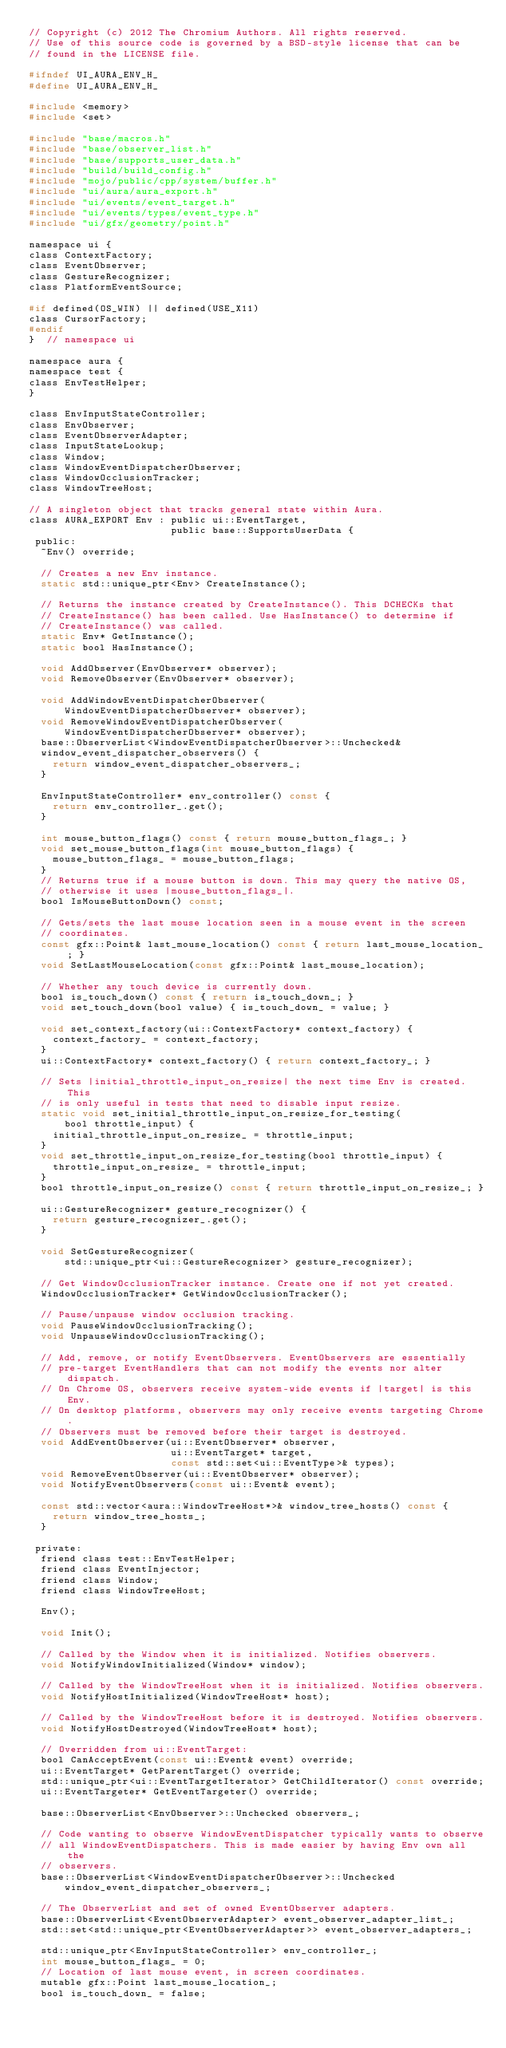Convert code to text. <code><loc_0><loc_0><loc_500><loc_500><_C_>// Copyright (c) 2012 The Chromium Authors. All rights reserved.
// Use of this source code is governed by a BSD-style license that can be
// found in the LICENSE file.

#ifndef UI_AURA_ENV_H_
#define UI_AURA_ENV_H_

#include <memory>
#include <set>

#include "base/macros.h"
#include "base/observer_list.h"
#include "base/supports_user_data.h"
#include "build/build_config.h"
#include "mojo/public/cpp/system/buffer.h"
#include "ui/aura/aura_export.h"
#include "ui/events/event_target.h"
#include "ui/events/types/event_type.h"
#include "ui/gfx/geometry/point.h"

namespace ui {
class ContextFactory;
class EventObserver;
class GestureRecognizer;
class PlatformEventSource;

#if defined(OS_WIN) || defined(USE_X11)
class CursorFactory;
#endif
}  // namespace ui

namespace aura {
namespace test {
class EnvTestHelper;
}

class EnvInputStateController;
class EnvObserver;
class EventObserverAdapter;
class InputStateLookup;
class Window;
class WindowEventDispatcherObserver;
class WindowOcclusionTracker;
class WindowTreeHost;

// A singleton object that tracks general state within Aura.
class AURA_EXPORT Env : public ui::EventTarget,
                        public base::SupportsUserData {
 public:
  ~Env() override;

  // Creates a new Env instance.
  static std::unique_ptr<Env> CreateInstance();

  // Returns the instance created by CreateInstance(). This DCHECKs that
  // CreateInstance() has been called. Use HasInstance() to determine if
  // CreateInstance() was called.
  static Env* GetInstance();
  static bool HasInstance();

  void AddObserver(EnvObserver* observer);
  void RemoveObserver(EnvObserver* observer);

  void AddWindowEventDispatcherObserver(
      WindowEventDispatcherObserver* observer);
  void RemoveWindowEventDispatcherObserver(
      WindowEventDispatcherObserver* observer);
  base::ObserverList<WindowEventDispatcherObserver>::Unchecked&
  window_event_dispatcher_observers() {
    return window_event_dispatcher_observers_;
  }

  EnvInputStateController* env_controller() const {
    return env_controller_.get();
  }

  int mouse_button_flags() const { return mouse_button_flags_; }
  void set_mouse_button_flags(int mouse_button_flags) {
    mouse_button_flags_ = mouse_button_flags;
  }
  // Returns true if a mouse button is down. This may query the native OS,
  // otherwise it uses |mouse_button_flags_|.
  bool IsMouseButtonDown() const;

  // Gets/sets the last mouse location seen in a mouse event in the screen
  // coordinates.
  const gfx::Point& last_mouse_location() const { return last_mouse_location_; }
  void SetLastMouseLocation(const gfx::Point& last_mouse_location);

  // Whether any touch device is currently down.
  bool is_touch_down() const { return is_touch_down_; }
  void set_touch_down(bool value) { is_touch_down_ = value; }

  void set_context_factory(ui::ContextFactory* context_factory) {
    context_factory_ = context_factory;
  }
  ui::ContextFactory* context_factory() { return context_factory_; }

  // Sets |initial_throttle_input_on_resize| the next time Env is created. This
  // is only useful in tests that need to disable input resize.
  static void set_initial_throttle_input_on_resize_for_testing(
      bool throttle_input) {
    initial_throttle_input_on_resize_ = throttle_input;
  }
  void set_throttle_input_on_resize_for_testing(bool throttle_input) {
    throttle_input_on_resize_ = throttle_input;
  }
  bool throttle_input_on_resize() const { return throttle_input_on_resize_; }

  ui::GestureRecognizer* gesture_recognizer() {
    return gesture_recognizer_.get();
  }

  void SetGestureRecognizer(
      std::unique_ptr<ui::GestureRecognizer> gesture_recognizer);

  // Get WindowOcclusionTracker instance. Create one if not yet created.
  WindowOcclusionTracker* GetWindowOcclusionTracker();

  // Pause/unpause window occlusion tracking.
  void PauseWindowOcclusionTracking();
  void UnpauseWindowOcclusionTracking();

  // Add, remove, or notify EventObservers. EventObservers are essentially
  // pre-target EventHandlers that can not modify the events nor alter dispatch.
  // On Chrome OS, observers receive system-wide events if |target| is this Env.
  // On desktop platforms, observers may only receive events targeting Chrome.
  // Observers must be removed before their target is destroyed.
  void AddEventObserver(ui::EventObserver* observer,
                        ui::EventTarget* target,
                        const std::set<ui::EventType>& types);
  void RemoveEventObserver(ui::EventObserver* observer);
  void NotifyEventObservers(const ui::Event& event);

  const std::vector<aura::WindowTreeHost*>& window_tree_hosts() const {
    return window_tree_hosts_;
  }

 private:
  friend class test::EnvTestHelper;
  friend class EventInjector;
  friend class Window;
  friend class WindowTreeHost;

  Env();

  void Init();

  // Called by the Window when it is initialized. Notifies observers.
  void NotifyWindowInitialized(Window* window);

  // Called by the WindowTreeHost when it is initialized. Notifies observers.
  void NotifyHostInitialized(WindowTreeHost* host);

  // Called by the WindowTreeHost before it is destroyed. Notifies observers.
  void NotifyHostDestroyed(WindowTreeHost* host);

  // Overridden from ui::EventTarget:
  bool CanAcceptEvent(const ui::Event& event) override;
  ui::EventTarget* GetParentTarget() override;
  std::unique_ptr<ui::EventTargetIterator> GetChildIterator() const override;
  ui::EventTargeter* GetEventTargeter() override;

  base::ObserverList<EnvObserver>::Unchecked observers_;

  // Code wanting to observe WindowEventDispatcher typically wants to observe
  // all WindowEventDispatchers. This is made easier by having Env own all the
  // observers.
  base::ObserverList<WindowEventDispatcherObserver>::Unchecked
      window_event_dispatcher_observers_;

  // The ObserverList and set of owned EventObserver adapters.
  base::ObserverList<EventObserverAdapter> event_observer_adapter_list_;
  std::set<std::unique_ptr<EventObserverAdapter>> event_observer_adapters_;

  std::unique_ptr<EnvInputStateController> env_controller_;
  int mouse_button_flags_ = 0;
  // Location of last mouse event, in screen coordinates.
  mutable gfx::Point last_mouse_location_;
  bool is_touch_down_ = false;
</code> 